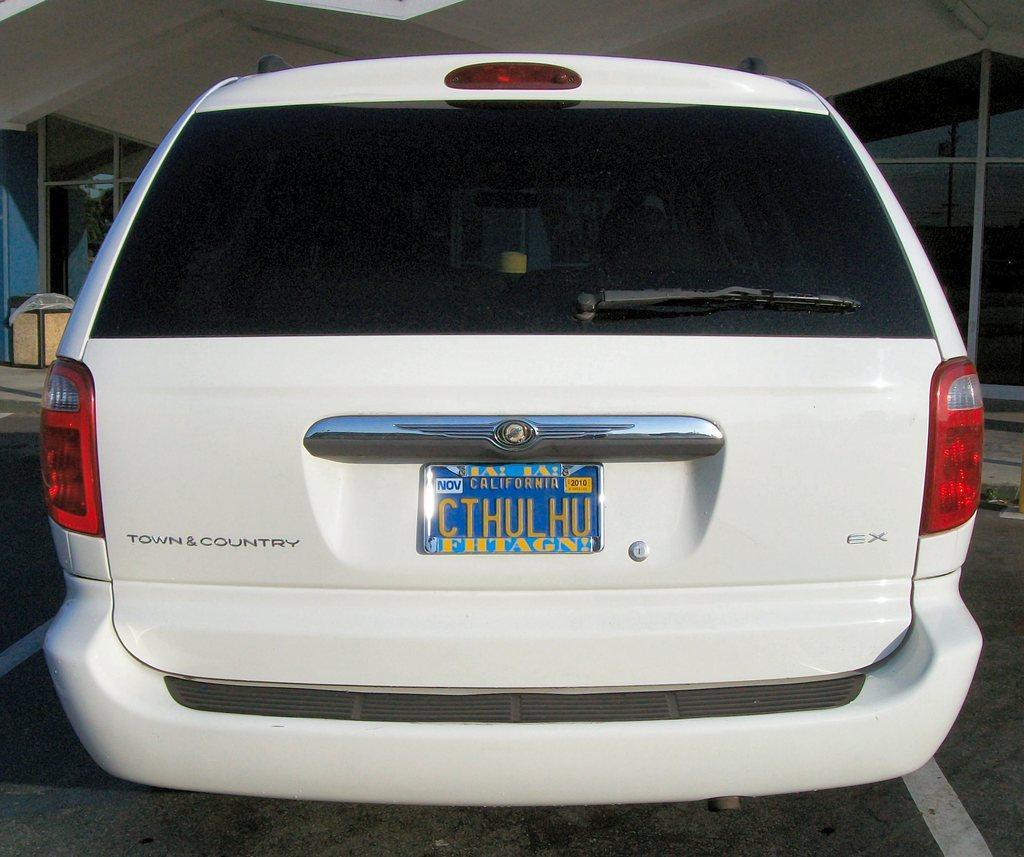How would you summarize this image in a sentence or two? In this picture we can see a car. 